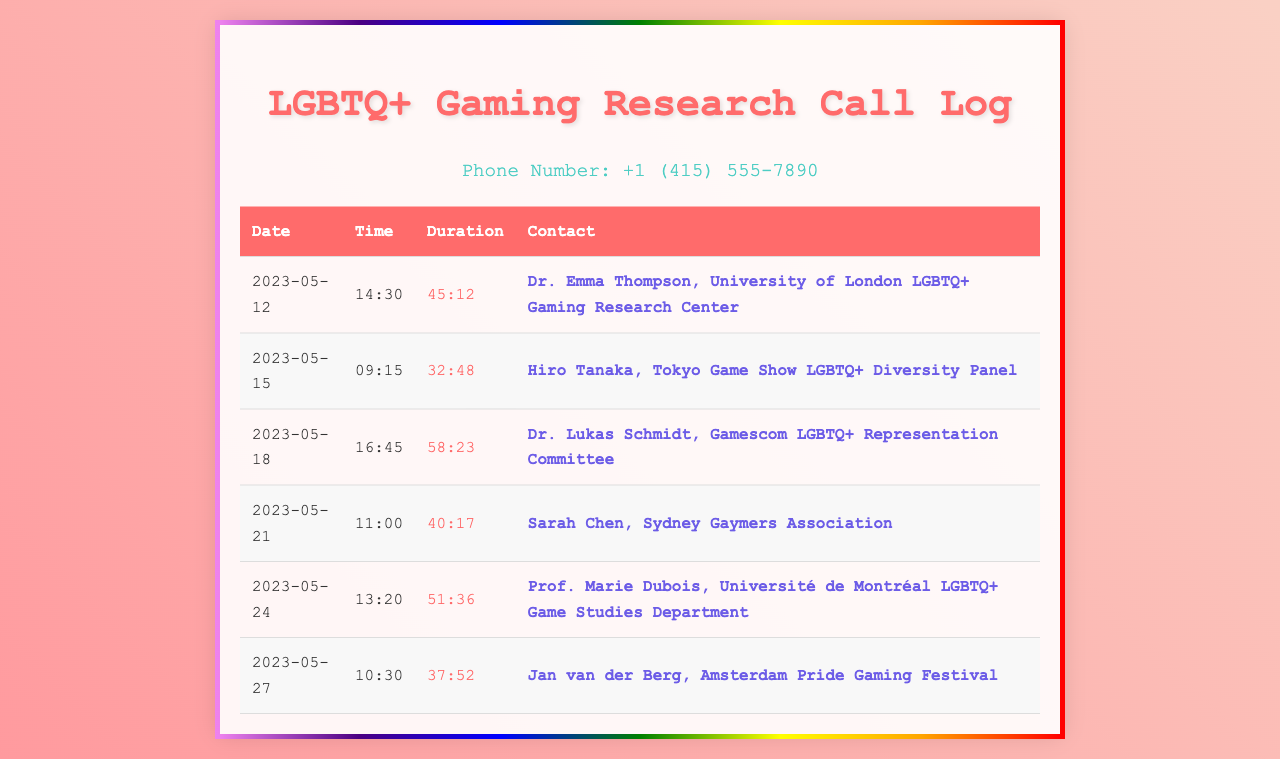What is the phone number listed? The phone number is provided at the top of the document, which is +1 (415) 555-7890.
Answer: +1 (415) 555-7890 Who is the contact for the Tokyo Game Show LGBTQ+ Diversity Panel? The contact's name is mentioned in the corresponding row of the table, which is Hiro Tanaka.
Answer: Hiro Tanaka What was the duration of the call to Dr. Emma Thompson? The duration is listed in the table for the call made on 2023-05-12, which is 45:12.
Answer: 45:12 On what date was the call to the Université de Montréal LGBTQ+ Game Studies Department made? The date is found in the row corresponding to Prof. Marie Dubois in the table, which is 2023-05-24.
Answer: 2023-05-24 How many calls were made to LGBTQ+ gaming communities in total? The total number of rows in the call log indicates the number of calls made, which is 6.
Answer: 6 Which contact has the longest call duration? To find this, we compare the durations given; Dr. Lukas Schmidt's call duration of 58:23 is the longest.
Answer: Dr. Lukas Schmidt What is the average duration of the calls listed? The total duration of the calls divided by the number of calls gives the average duration, calculated by summing all durations and dividing by 6.
Answer: 45:21 Which city is associated with Sarah Chen? The city can be found in the contact's description, which is Sydney.
Answer: Sydney What is the purpose of the calls listed in the document? The purpose is indicated by the context of the document, which is for research collaboration within LGBTQ+ gaming communities.
Answer: Research collaboration 